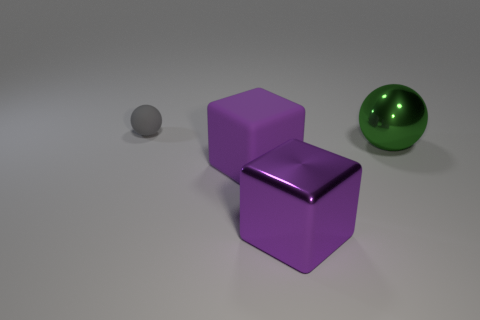Subtract 1 blocks. How many blocks are left? 1 Add 1 large cyan blocks. How many objects exist? 5 Subtract all green spheres. How many spheres are left? 1 Subtract all blue matte cubes. Subtract all purple rubber things. How many objects are left? 3 Add 3 gray balls. How many gray balls are left? 4 Add 3 purple balls. How many purple balls exist? 3 Subtract 0 blue blocks. How many objects are left? 4 Subtract all gray balls. Subtract all red blocks. How many balls are left? 1 Subtract all yellow cubes. How many gray balls are left? 1 